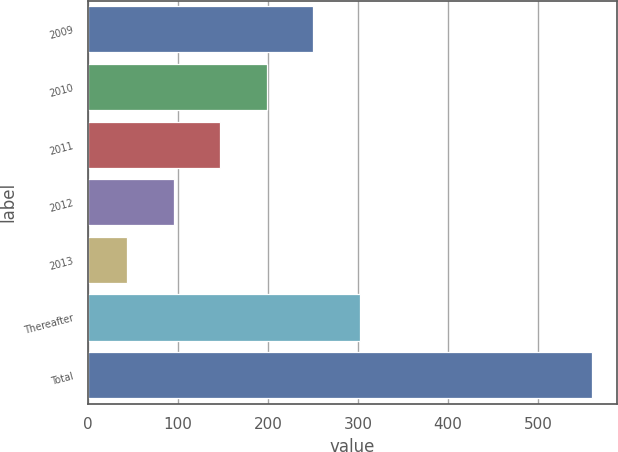Convert chart to OTSL. <chart><loc_0><loc_0><loc_500><loc_500><bar_chart><fcel>2009<fcel>2010<fcel>2011<fcel>2012<fcel>2013<fcel>Thereafter<fcel>Total<nl><fcel>250.4<fcel>198.8<fcel>147.2<fcel>95.6<fcel>44<fcel>302<fcel>560<nl></chart> 